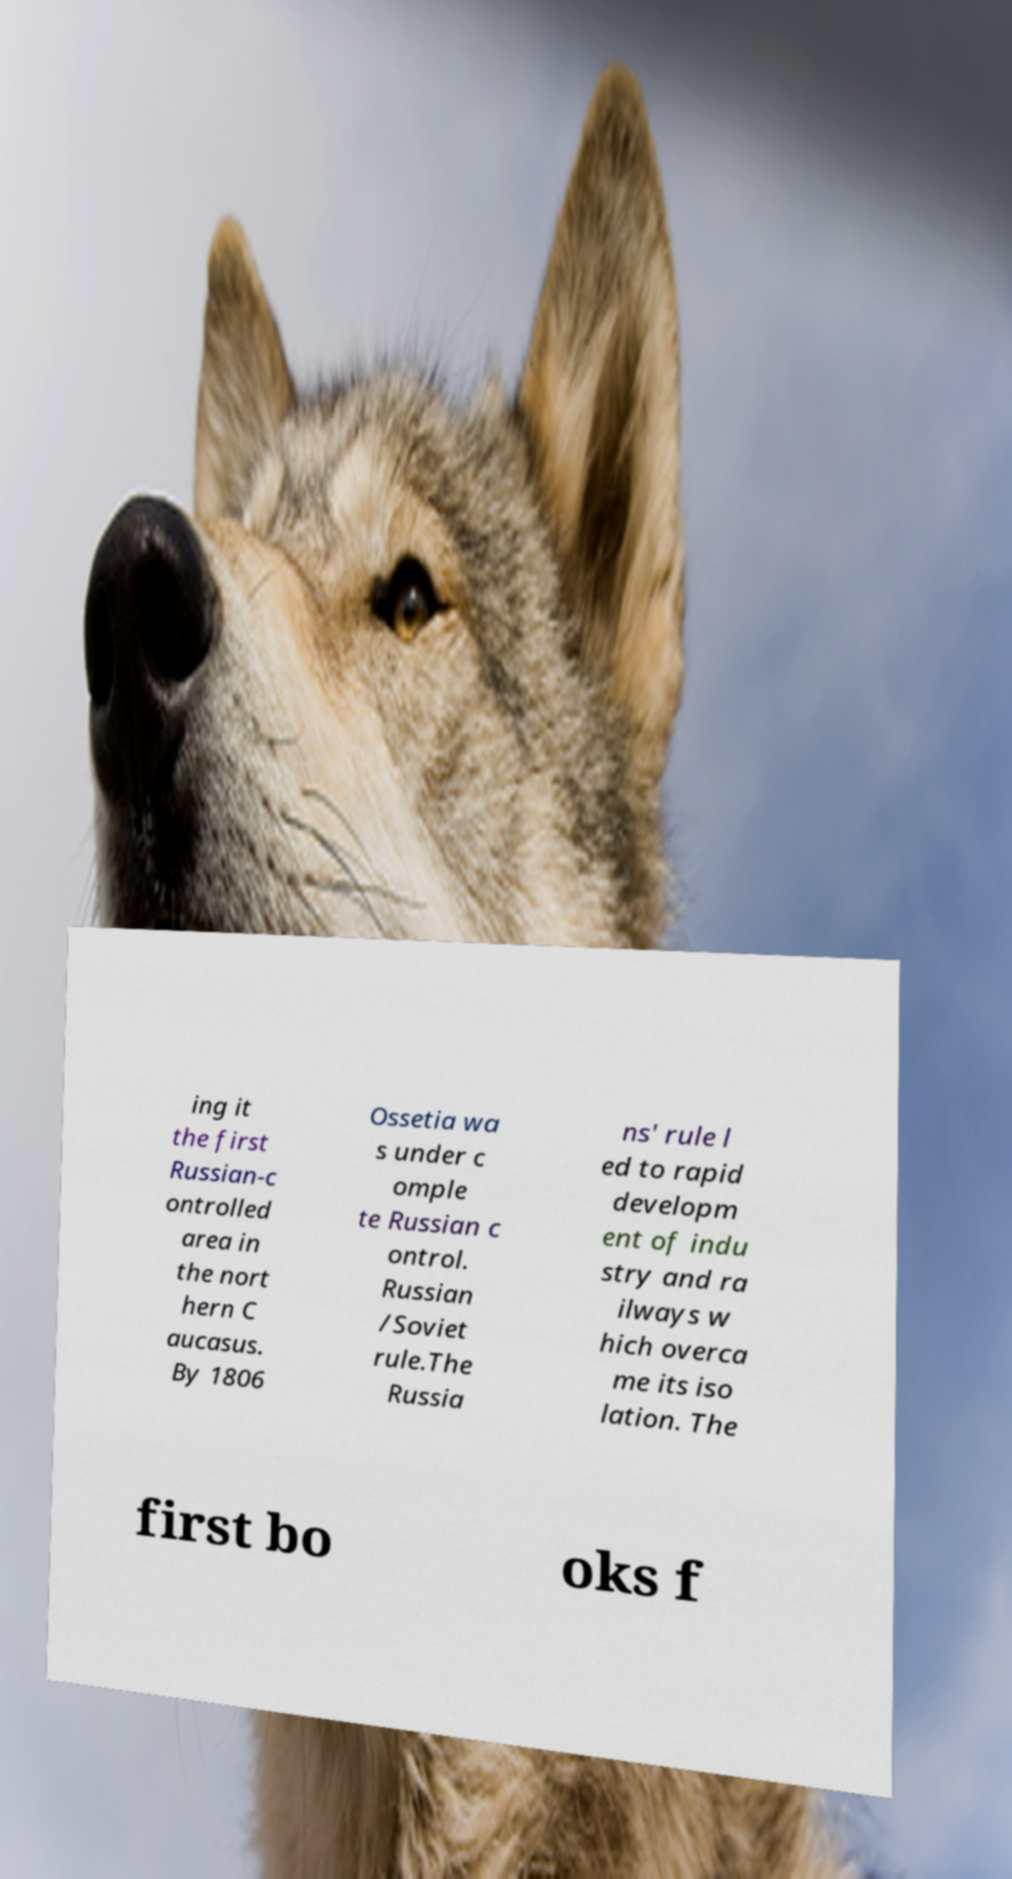For documentation purposes, I need the text within this image transcribed. Could you provide that? ing it the first Russian-c ontrolled area in the nort hern C aucasus. By 1806 Ossetia wa s under c omple te Russian c ontrol. Russian /Soviet rule.The Russia ns' rule l ed to rapid developm ent of indu stry and ra ilways w hich overca me its iso lation. The first bo oks f 